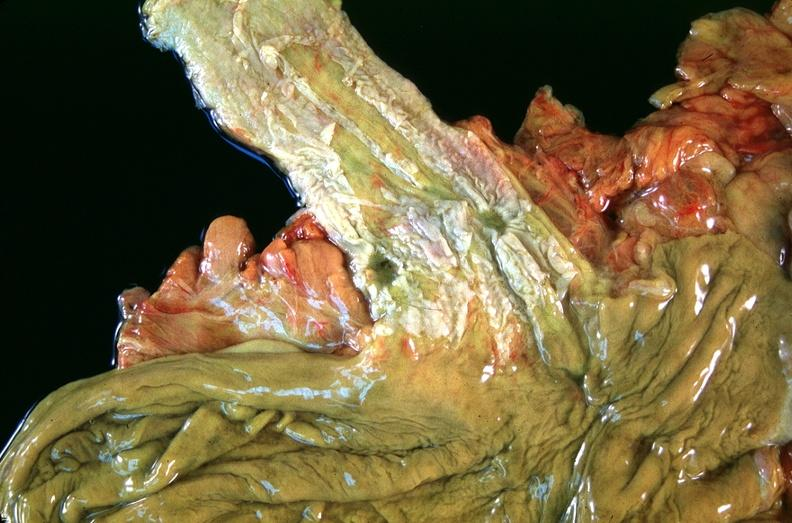what does this image show?
Answer the question using a single word or phrase. Esophogus 